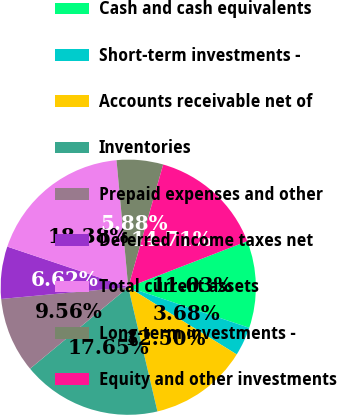Convert chart. <chart><loc_0><loc_0><loc_500><loc_500><pie_chart><fcel>Cash and cash equivalents<fcel>Short-term investments -<fcel>Accounts receivable net of<fcel>Inventories<fcel>Prepaid expenses and other<fcel>Deferred income taxes net<fcel>Total current assets<fcel>Long-term investments -<fcel>Equity and other investments<nl><fcel>11.03%<fcel>3.68%<fcel>12.5%<fcel>17.65%<fcel>9.56%<fcel>6.62%<fcel>18.38%<fcel>5.88%<fcel>14.71%<nl></chart> 